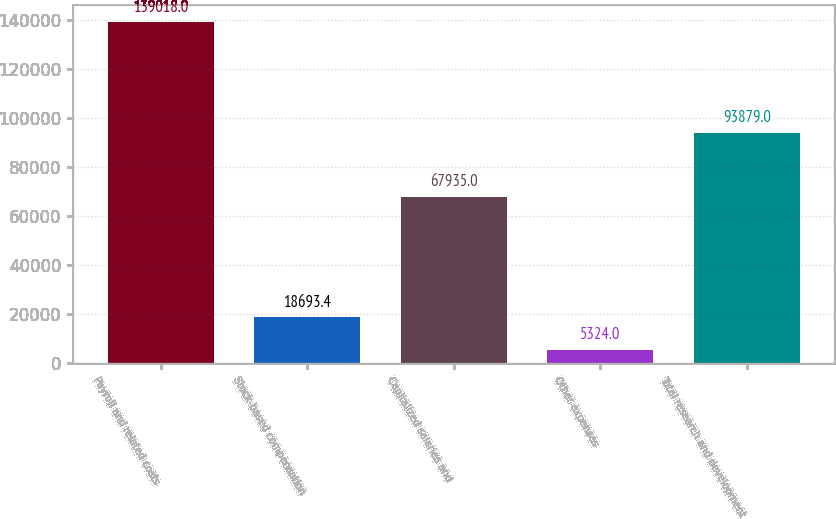<chart> <loc_0><loc_0><loc_500><loc_500><bar_chart><fcel>Payroll and related costs<fcel>Stock-based compensation<fcel>Capitalized salaries and<fcel>Other expenses<fcel>Total research and development<nl><fcel>139018<fcel>18693.4<fcel>67935<fcel>5324<fcel>93879<nl></chart> 